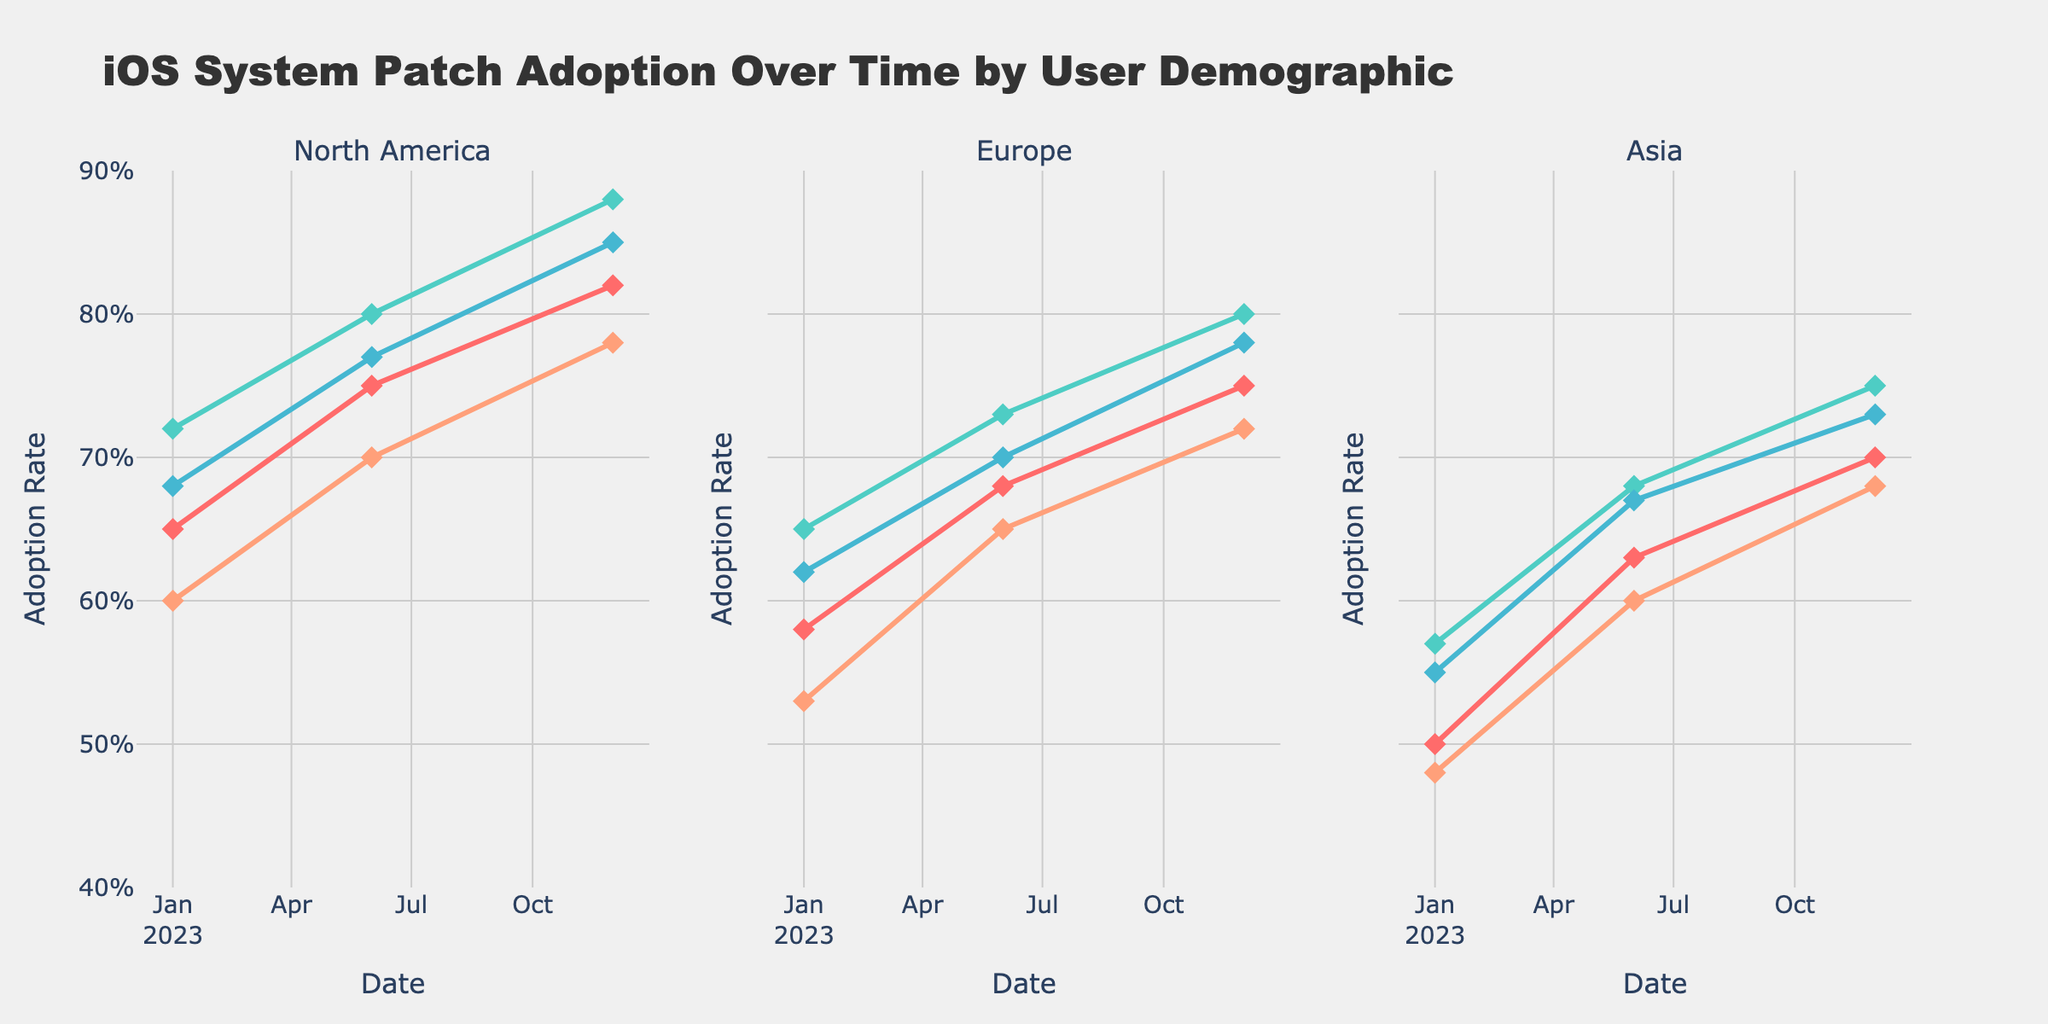Which age group in North America had the highest adoption rate on December 1, 2023? To find the highest adoption rate on December 1, 2023, for North America, locate the North America subplot and the data points corresponding to December 1, 2023. Identify the age group with the highest position on the y-axis.
Answer: 25-34 Which region showed the lowest iOS adoption rate for the 45+ age group on January 1, 2023? To determine which region had the lowest adoption rate for the 45+ age group on January 1, 2023, find the relevant data points for the 45+ age group across North America, Europe, and Asia on January 1, 2023. The lowest position on the y-axis indicates the lowest adoption rate.
Answer: Asia How did the adoption rate for the age group 18-24 in Europe change from January 1, 2023, to December 1, 2023? Track the trajectory of the line corresponding to the 18-24 age group in Europe from January 1, 2023, to December 1, 2023. Note the y-values at these two dates and compute the difference to know the change.
Answer: Increased by 0.17 Which age group in Asia exhibited the highest increase in adoption rate between January 1, 2023, and June 1, 2023? Review the adoption rates for all age groups in Asia on January 1, 2023, and June 1, 2023. Calculate the difference between these dates for each age group and identify the highest increase.
Answer: 18-24 What was the adoption rate trend for the 35-44 age group across all regions from the start to the end of 2023? Examine the lines for the 35-44 age group in each of the subplots (North America, Europe, Asia) from January 1, 2023, to December 1, 2023. Observe whether these lines generally move upwards, indicating an increase over time.
Answer: Increasing Which region had the most consistent adoption rate increase for the 25-34 age group during 2023? Compare the lines for the 25-34 age group in North America, Europe, and Asia subplots from January 1, 2023, to December 1, 2023. The most consistent increase would be indicated by a steady upward slope.
Answer: North America What was the adoption rate for the 45+ age group in Europe on June 1, 2023? Locate the subplot for Europe and find the data point corresponding to the 45+ age group on June 1, 2023. The y-value at this point is the required adoption rate.
Answer: 0.65 Between January 1, 2023, and December 1, 2023, which age group in North America exhibited the smallest adoption rate increase? Compare the adoption rates for all age groups in North America on January 1, 2023, and December 1, 2023. Calculate the difference for each age group and identify the smallest increase.
Answer: 45+ Which age group and region combination noted the highest adoption rate across all three recorded dates? Check the highest points on the y-axis for all plotted age groups in all regions on January 1, 2023, June 1, 2023, and December 1, 2023. Identify the combination with the maximum value.
Answer: 25-34 in North America How does the adoption rate trend for the 18-24 age group in Asia compare to the same age group in North America over the year 2023? Compare the lines representing the 18-24 age group for both Asia and North America subplots from January 1, 2023, to December 1, 2023. Note the general direction and steepness of both lines.
Answer: Both increasing, but North America's increase is steeper 